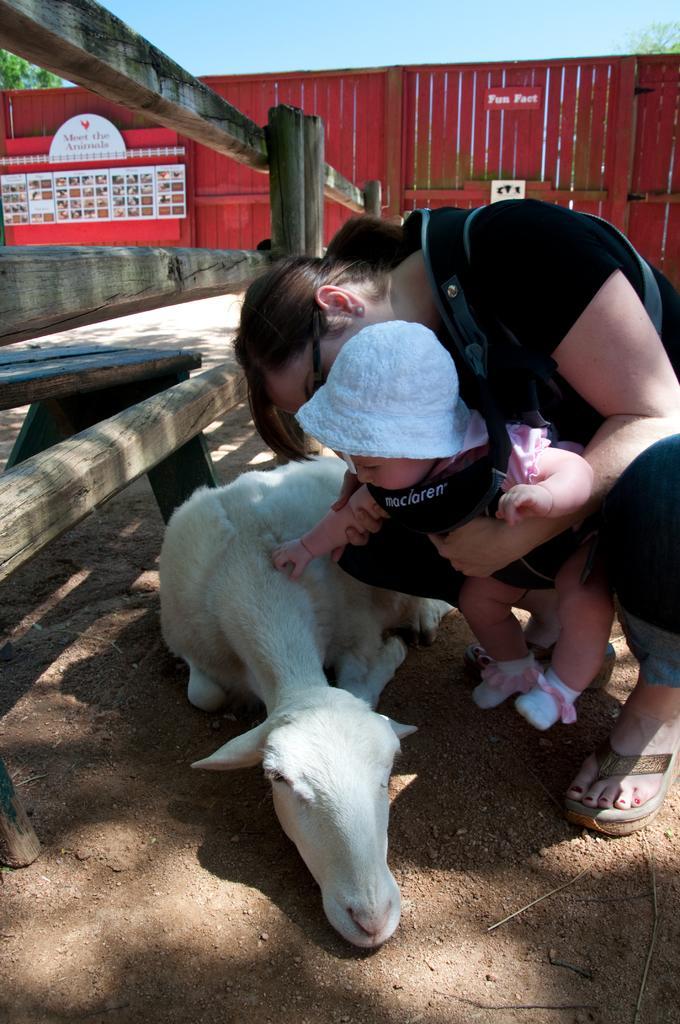How would you summarize this image in a sentence or two? Here in this picture we can see an woman holding a baby in her hand and we can see the baby is wearing a hat on her and she is touching the goat which is present in front of her on the ground over there and behind them we can see a container present and we can see trees in the far and and beside them we can see a wooden railing present over there. 